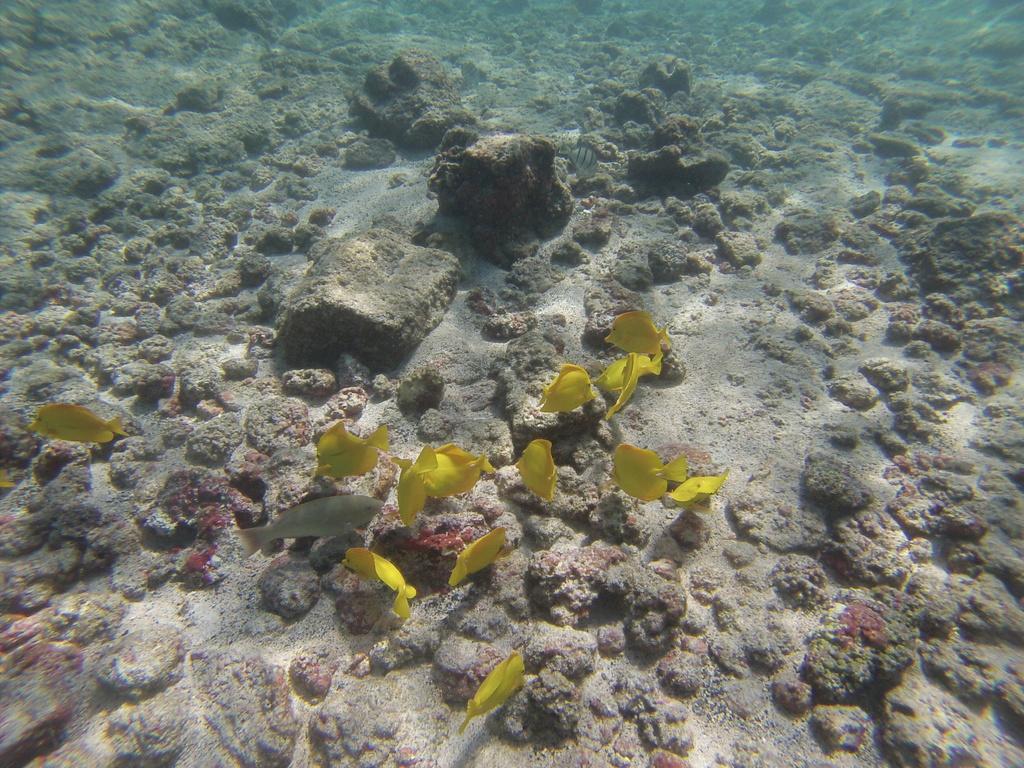Could you give a brief overview of what you see in this image? This seems like a water body and here we can see fishes and there are rocks. 